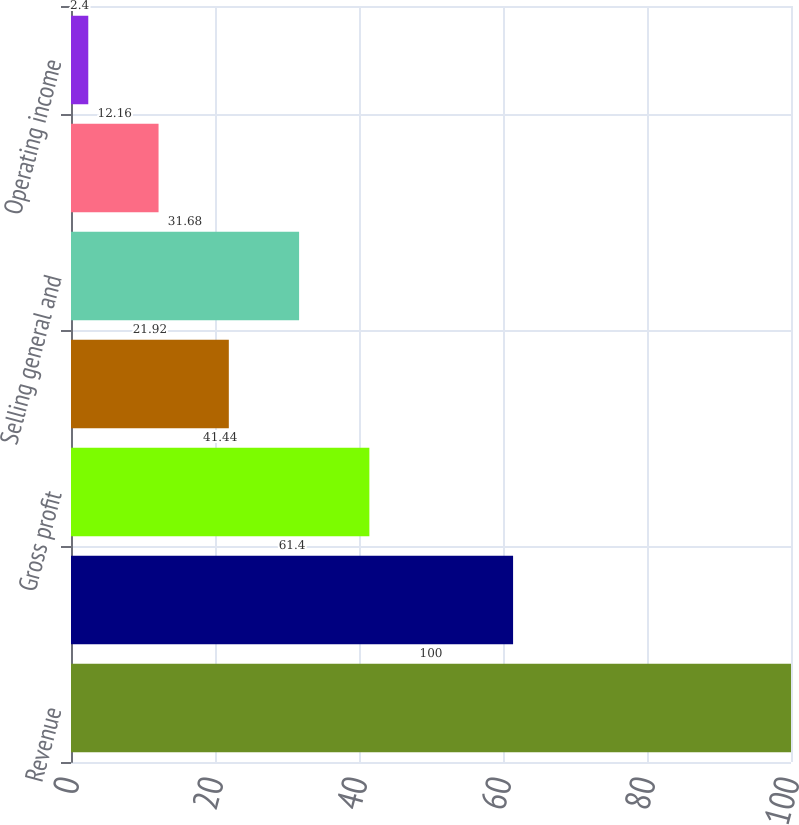Convert chart to OTSL. <chart><loc_0><loc_0><loc_500><loc_500><bar_chart><fcel>Revenue<fcel>Cost of goods sold<fcel>Gross profit<fcel>Research and development<fcel>Selling general and<fcel>Other operating expense<fcel>Operating income<nl><fcel>100<fcel>61.4<fcel>41.44<fcel>21.92<fcel>31.68<fcel>12.16<fcel>2.4<nl></chart> 